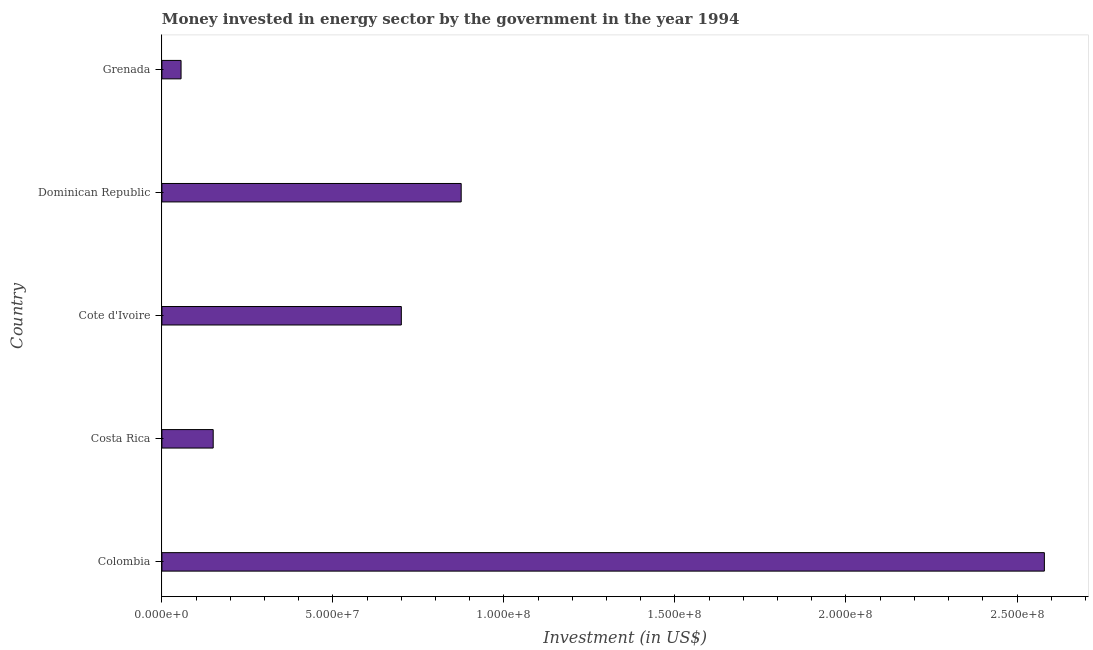Does the graph contain grids?
Your answer should be compact. No. What is the title of the graph?
Your answer should be very brief. Money invested in energy sector by the government in the year 1994. What is the label or title of the X-axis?
Give a very brief answer. Investment (in US$). What is the label or title of the Y-axis?
Provide a succinct answer. Country. What is the investment in energy in Dominican Republic?
Give a very brief answer. 8.75e+07. Across all countries, what is the maximum investment in energy?
Provide a succinct answer. 2.58e+08. Across all countries, what is the minimum investment in energy?
Your answer should be compact. 5.60e+06. In which country was the investment in energy minimum?
Provide a succinct answer. Grenada. What is the sum of the investment in energy?
Keep it short and to the point. 4.36e+08. What is the difference between the investment in energy in Costa Rica and Dominican Republic?
Offer a terse response. -7.25e+07. What is the average investment in energy per country?
Your answer should be very brief. 8.72e+07. What is the median investment in energy?
Make the answer very short. 7.00e+07. In how many countries, is the investment in energy greater than 130000000 US$?
Make the answer very short. 1. What is the ratio of the investment in energy in Colombia to that in Dominican Republic?
Provide a short and direct response. 2.95. Is the investment in energy in Costa Rica less than that in Dominican Republic?
Keep it short and to the point. Yes. Is the difference between the investment in energy in Cote d'Ivoire and Dominican Republic greater than the difference between any two countries?
Offer a terse response. No. What is the difference between the highest and the second highest investment in energy?
Your answer should be very brief. 1.70e+08. What is the difference between the highest and the lowest investment in energy?
Provide a short and direct response. 2.52e+08. In how many countries, is the investment in energy greater than the average investment in energy taken over all countries?
Keep it short and to the point. 2. How many bars are there?
Give a very brief answer. 5. How many countries are there in the graph?
Offer a terse response. 5. What is the Investment (in US$) of Colombia?
Provide a short and direct response. 2.58e+08. What is the Investment (in US$) of Costa Rica?
Make the answer very short. 1.50e+07. What is the Investment (in US$) of Cote d'Ivoire?
Provide a short and direct response. 7.00e+07. What is the Investment (in US$) of Dominican Republic?
Provide a short and direct response. 8.75e+07. What is the Investment (in US$) in Grenada?
Your response must be concise. 5.60e+06. What is the difference between the Investment (in US$) in Colombia and Costa Rica?
Provide a succinct answer. 2.43e+08. What is the difference between the Investment (in US$) in Colombia and Cote d'Ivoire?
Keep it short and to the point. 1.88e+08. What is the difference between the Investment (in US$) in Colombia and Dominican Republic?
Your answer should be very brief. 1.70e+08. What is the difference between the Investment (in US$) in Colombia and Grenada?
Offer a terse response. 2.52e+08. What is the difference between the Investment (in US$) in Costa Rica and Cote d'Ivoire?
Ensure brevity in your answer.  -5.50e+07. What is the difference between the Investment (in US$) in Costa Rica and Dominican Republic?
Keep it short and to the point. -7.25e+07. What is the difference between the Investment (in US$) in Costa Rica and Grenada?
Offer a very short reply. 9.40e+06. What is the difference between the Investment (in US$) in Cote d'Ivoire and Dominican Republic?
Your response must be concise. -1.75e+07. What is the difference between the Investment (in US$) in Cote d'Ivoire and Grenada?
Offer a very short reply. 6.44e+07. What is the difference between the Investment (in US$) in Dominican Republic and Grenada?
Offer a very short reply. 8.19e+07. What is the ratio of the Investment (in US$) in Colombia to that in Costa Rica?
Provide a short and direct response. 17.2. What is the ratio of the Investment (in US$) in Colombia to that in Cote d'Ivoire?
Provide a succinct answer. 3.69. What is the ratio of the Investment (in US$) in Colombia to that in Dominican Republic?
Provide a short and direct response. 2.95. What is the ratio of the Investment (in US$) in Colombia to that in Grenada?
Make the answer very short. 46.07. What is the ratio of the Investment (in US$) in Costa Rica to that in Cote d'Ivoire?
Keep it short and to the point. 0.21. What is the ratio of the Investment (in US$) in Costa Rica to that in Dominican Republic?
Your response must be concise. 0.17. What is the ratio of the Investment (in US$) in Costa Rica to that in Grenada?
Give a very brief answer. 2.68. What is the ratio of the Investment (in US$) in Cote d'Ivoire to that in Dominican Republic?
Offer a very short reply. 0.8. What is the ratio of the Investment (in US$) in Cote d'Ivoire to that in Grenada?
Your response must be concise. 12.5. What is the ratio of the Investment (in US$) in Dominican Republic to that in Grenada?
Provide a short and direct response. 15.62. 